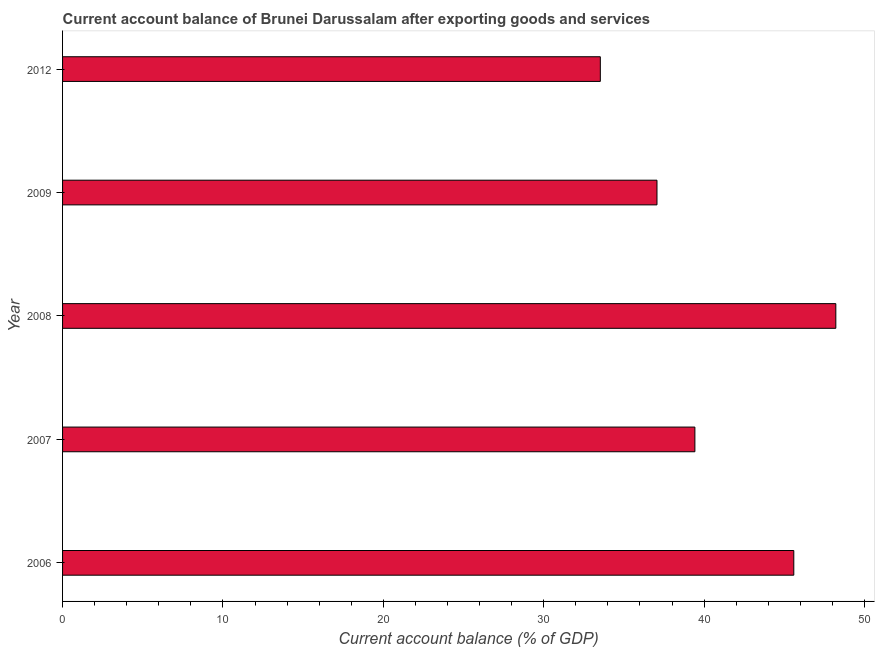What is the title of the graph?
Give a very brief answer. Current account balance of Brunei Darussalam after exporting goods and services. What is the label or title of the X-axis?
Provide a succinct answer. Current account balance (% of GDP). What is the label or title of the Y-axis?
Provide a short and direct response. Year. What is the current account balance in 2007?
Ensure brevity in your answer.  39.42. Across all years, what is the maximum current account balance?
Provide a short and direct response. 48.21. Across all years, what is the minimum current account balance?
Offer a very short reply. 33.53. In which year was the current account balance minimum?
Provide a short and direct response. 2012. What is the sum of the current account balance?
Give a very brief answer. 203.81. What is the difference between the current account balance in 2008 and 2009?
Ensure brevity in your answer.  11.15. What is the average current account balance per year?
Make the answer very short. 40.76. What is the median current account balance?
Provide a succinct answer. 39.42. In how many years, is the current account balance greater than 34 %?
Your response must be concise. 4. What is the ratio of the current account balance in 2006 to that in 2008?
Provide a short and direct response. 0.95. Is the current account balance in 2007 less than that in 2009?
Provide a succinct answer. No. Is the difference between the current account balance in 2006 and 2012 greater than the difference between any two years?
Keep it short and to the point. No. What is the difference between the highest and the second highest current account balance?
Keep it short and to the point. 2.62. What is the difference between the highest and the lowest current account balance?
Provide a succinct answer. 14.68. In how many years, is the current account balance greater than the average current account balance taken over all years?
Give a very brief answer. 2. How many bars are there?
Give a very brief answer. 5. What is the difference between two consecutive major ticks on the X-axis?
Give a very brief answer. 10. Are the values on the major ticks of X-axis written in scientific E-notation?
Offer a very short reply. No. What is the Current account balance (% of GDP) of 2006?
Provide a succinct answer. 45.59. What is the Current account balance (% of GDP) of 2007?
Your answer should be very brief. 39.42. What is the Current account balance (% of GDP) of 2008?
Ensure brevity in your answer.  48.21. What is the Current account balance (% of GDP) in 2009?
Make the answer very short. 37.06. What is the Current account balance (% of GDP) in 2012?
Offer a very short reply. 33.53. What is the difference between the Current account balance (% of GDP) in 2006 and 2007?
Your answer should be very brief. 6.17. What is the difference between the Current account balance (% of GDP) in 2006 and 2008?
Provide a short and direct response. -2.62. What is the difference between the Current account balance (% of GDP) in 2006 and 2009?
Offer a terse response. 8.53. What is the difference between the Current account balance (% of GDP) in 2006 and 2012?
Give a very brief answer. 12.06. What is the difference between the Current account balance (% of GDP) in 2007 and 2008?
Provide a succinct answer. -8.79. What is the difference between the Current account balance (% of GDP) in 2007 and 2009?
Keep it short and to the point. 2.36. What is the difference between the Current account balance (% of GDP) in 2007 and 2012?
Your answer should be compact. 5.9. What is the difference between the Current account balance (% of GDP) in 2008 and 2009?
Your answer should be compact. 11.15. What is the difference between the Current account balance (% of GDP) in 2008 and 2012?
Ensure brevity in your answer.  14.68. What is the difference between the Current account balance (% of GDP) in 2009 and 2012?
Keep it short and to the point. 3.53. What is the ratio of the Current account balance (% of GDP) in 2006 to that in 2007?
Ensure brevity in your answer.  1.16. What is the ratio of the Current account balance (% of GDP) in 2006 to that in 2008?
Provide a succinct answer. 0.95. What is the ratio of the Current account balance (% of GDP) in 2006 to that in 2009?
Give a very brief answer. 1.23. What is the ratio of the Current account balance (% of GDP) in 2006 to that in 2012?
Make the answer very short. 1.36. What is the ratio of the Current account balance (% of GDP) in 2007 to that in 2008?
Keep it short and to the point. 0.82. What is the ratio of the Current account balance (% of GDP) in 2007 to that in 2009?
Offer a very short reply. 1.06. What is the ratio of the Current account balance (% of GDP) in 2007 to that in 2012?
Make the answer very short. 1.18. What is the ratio of the Current account balance (% of GDP) in 2008 to that in 2009?
Your response must be concise. 1.3. What is the ratio of the Current account balance (% of GDP) in 2008 to that in 2012?
Offer a terse response. 1.44. What is the ratio of the Current account balance (% of GDP) in 2009 to that in 2012?
Offer a terse response. 1.1. 